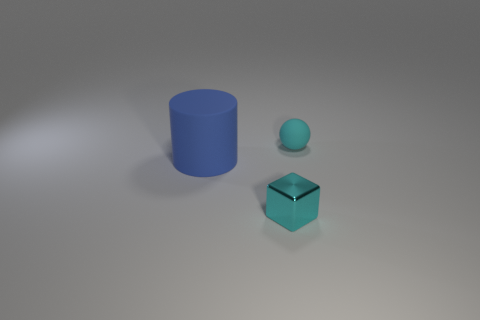What size is the thing in front of the thing left of the tiny shiny object that is on the right side of the big blue thing? The item in front of the object to the left of the tiny shiny object—which appears to be a blue sphere on the right side of a large blue cylinder—is a small turquoise cube. 